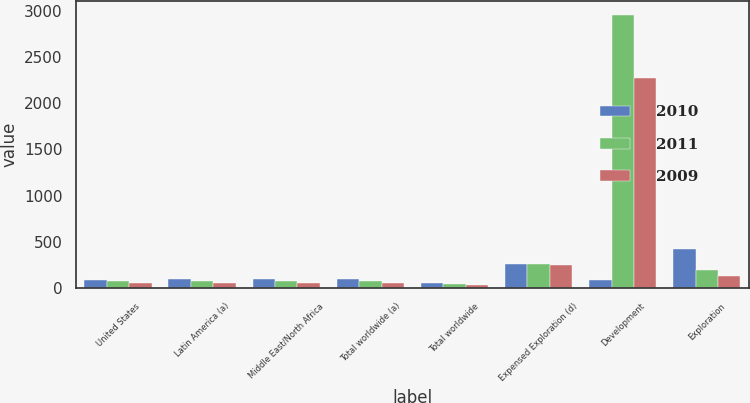<chart> <loc_0><loc_0><loc_500><loc_500><stacked_bar_chart><ecel><fcel>United States<fcel>Latin America (a)<fcel>Middle East/North Africa<fcel>Total worldwide (a)<fcel>Total worldwide<fcel>Expensed Exploration (d)<fcel>Development<fcel>Exploration<nl><fcel>2010<fcel>92.8<fcel>97.16<fcel>104.34<fcel>97.92<fcel>55.53<fcel>258<fcel>92.8<fcel>421<nl><fcel>2011<fcel>73.79<fcel>75.29<fcel>76.67<fcel>75.16<fcel>45.08<fcel>262<fcel>2955<fcel>194<nl><fcel>2009<fcel>56.74<fcel>55.89<fcel>58.75<fcel>57.31<fcel>34.27<fcel>254<fcel>2274<fcel>132<nl></chart> 